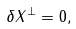<formula> <loc_0><loc_0><loc_500><loc_500>\delta X ^ { \perp } = 0 ,</formula> 